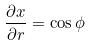Convert formula to latex. <formula><loc_0><loc_0><loc_500><loc_500>\frac { \partial x } { \partial r } = \cos \phi</formula> 